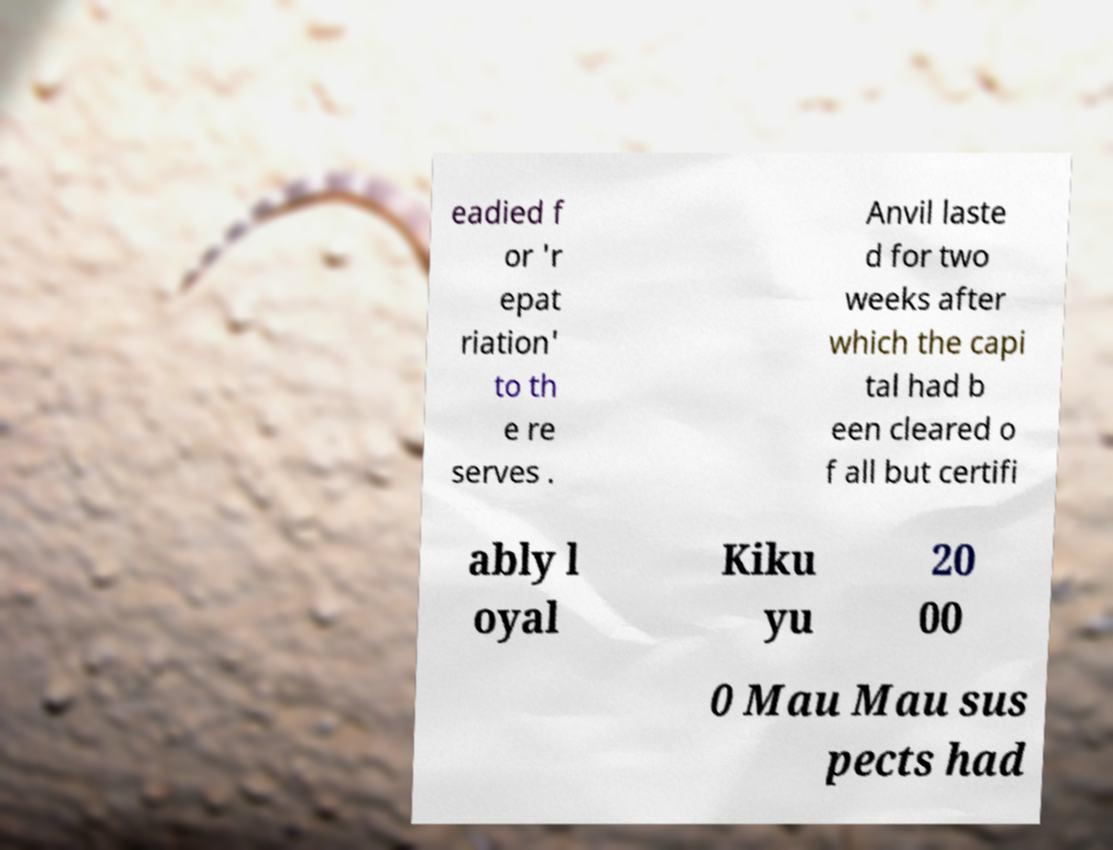Can you accurately transcribe the text from the provided image for me? eadied f or 'r epat riation' to th e re serves . Anvil laste d for two weeks after which the capi tal had b een cleared o f all but certifi ably l oyal Kiku yu 20 00 0 Mau Mau sus pects had 